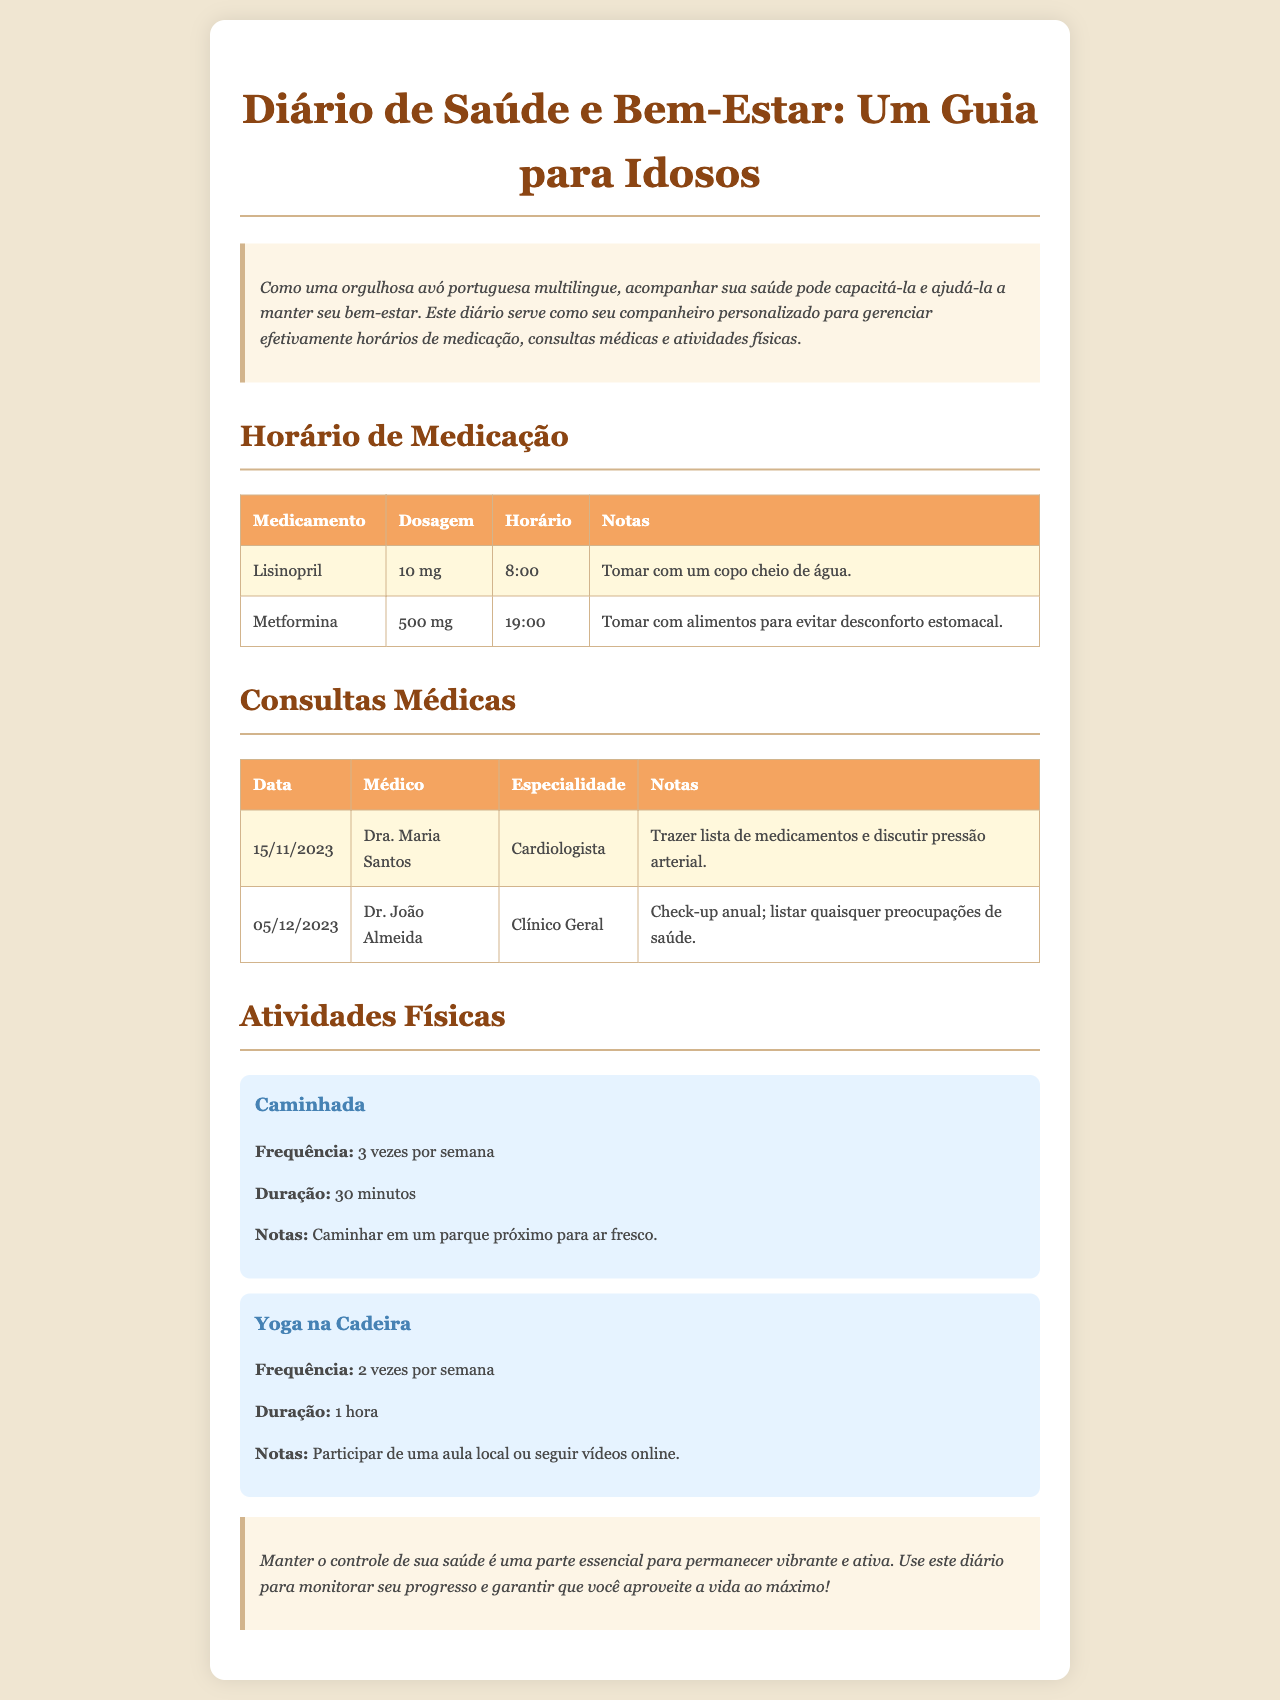Qual é o medicamento tomado às 8:00? O medicamento listado para ser tomado às 8:00 é o Lisinopril.
Answer: Lisinopril Quantas vezes por semana é recomendada a caminhada? O diário recomenda caminhadas 3 vezes por semana.
Answer: 3 vezes Quem é o médico marcado para o dia 15/11/2023? A tabela de consultas médicas menciona a Dra. Maria Santos como médica nesse dia.
Answer: Dra. Maria Santos Qual é a dosagem de Metformina? A dosagem de Metformina, conforme listado, é 500 mg.
Answer: 500 mg Quanto tempo dura a aula de yoga na cadeira? O diário indica que a duração da aula de yoga na cadeira é de 1 hora.
Answer: 1 hora Qué nota deve ser trazida para a consulta com o cardiologista? A nota que deve ser trazida é a lista de medicamentos e discutir pressão arterial.
Answer: Lista de medicamentos e discutir pressão arterial Quantas atividades de fitness estão listadas no documento? O documento lista duas atividades físicas: Caminhada e Yoga na Cadeira.
Answer: 2 Qual é a cor de fundo do diário? O documento apresenta um fundo na cor fendi.
Answer: Fendi Qual a especialidade do Dr. João Almeida? A especialidade do Dr. João Almeida é Clínico Geral.
Answer: Clínico Geral 